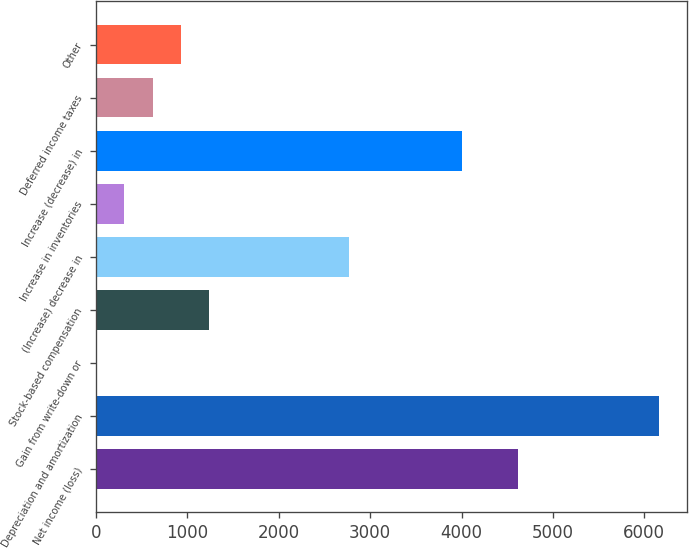<chart> <loc_0><loc_0><loc_500><loc_500><bar_chart><fcel>Net income (loss)<fcel>Depreciation and amortization<fcel>Gain from write-down or<fcel>Stock-based compensation<fcel>(Increase) decrease in<fcel>Increase in inventories<fcel>Increase (decrease) in<fcel>Deferred income taxes<fcel>Other<nl><fcel>4619<fcel>6158<fcel>2<fcel>1233.2<fcel>2772.2<fcel>309.8<fcel>4003.4<fcel>617.6<fcel>925.4<nl></chart> 